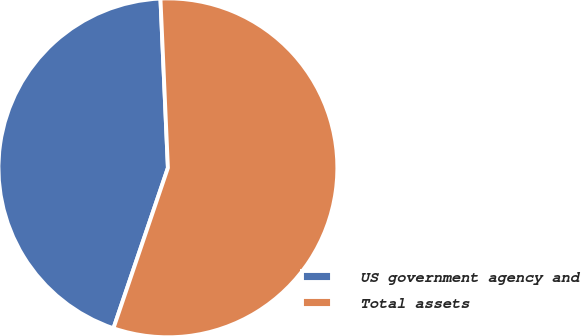Convert chart to OTSL. <chart><loc_0><loc_0><loc_500><loc_500><pie_chart><fcel>US government agency and<fcel>Total assets<nl><fcel>44.09%<fcel>55.91%<nl></chart> 